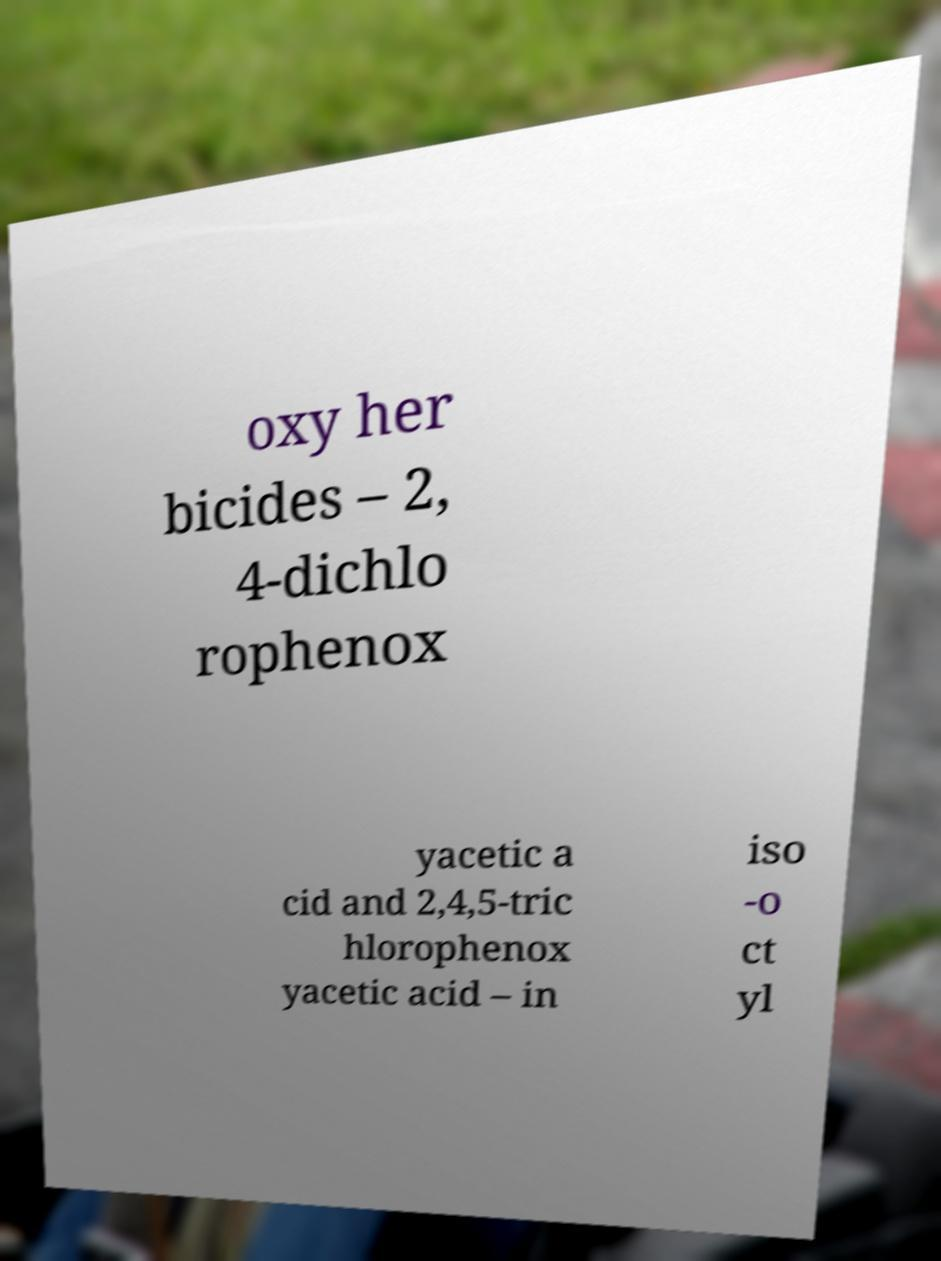There's text embedded in this image that I need extracted. Can you transcribe it verbatim? oxy her bicides – 2, 4-dichlo rophenox yacetic a cid and 2,4,5-tric hlorophenox yacetic acid – in iso -o ct yl 